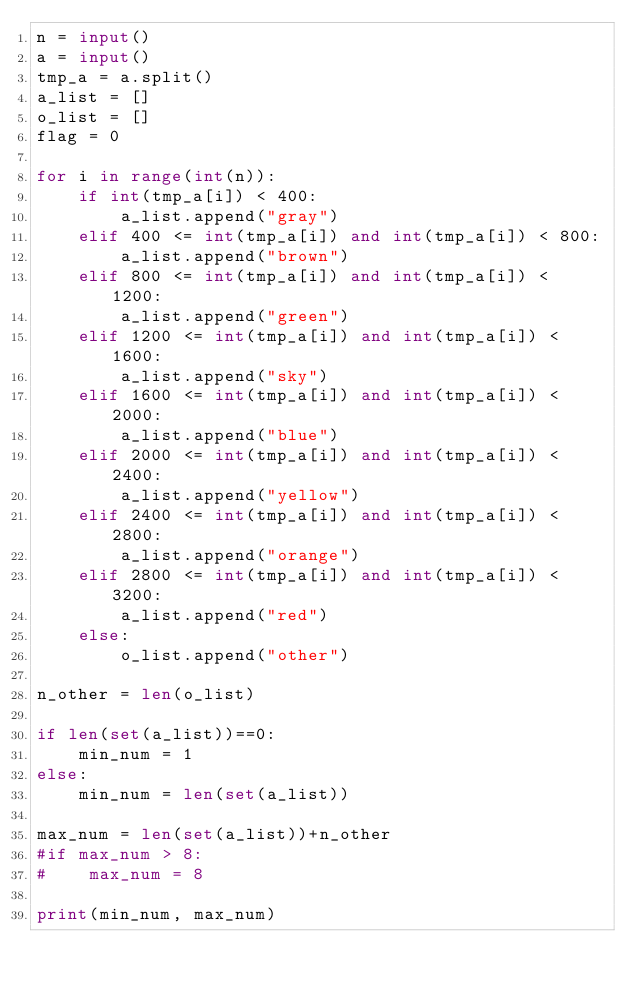Convert code to text. <code><loc_0><loc_0><loc_500><loc_500><_Python_>n = input()
a = input()
tmp_a = a.split()
a_list = []
o_list = []
flag = 0

for i in range(int(n)):
    if int(tmp_a[i]) < 400:
        a_list.append("gray")
    elif 400 <= int(tmp_a[i]) and int(tmp_a[i]) < 800:
        a_list.append("brown")
    elif 800 <= int(tmp_a[i]) and int(tmp_a[i]) < 1200:
        a_list.append("green")
    elif 1200 <= int(tmp_a[i]) and int(tmp_a[i]) < 1600:
        a_list.append("sky")
    elif 1600 <= int(tmp_a[i]) and int(tmp_a[i]) < 2000:
        a_list.append("blue")
    elif 2000 <= int(tmp_a[i]) and int(tmp_a[i]) < 2400:
        a_list.append("yellow")
    elif 2400 <= int(tmp_a[i]) and int(tmp_a[i]) < 2800:
        a_list.append("orange")
    elif 2800 <= int(tmp_a[i]) and int(tmp_a[i]) < 3200:
        a_list.append("red")
    else:
        o_list.append("other")

n_other = len(o_list)

if len(set(a_list))==0:
    min_num = 1
else:
    min_num = len(set(a_list))

max_num = len(set(a_list))+n_other
#if max_num > 8:
#    max_num = 8

print(min_num, max_num)
</code> 